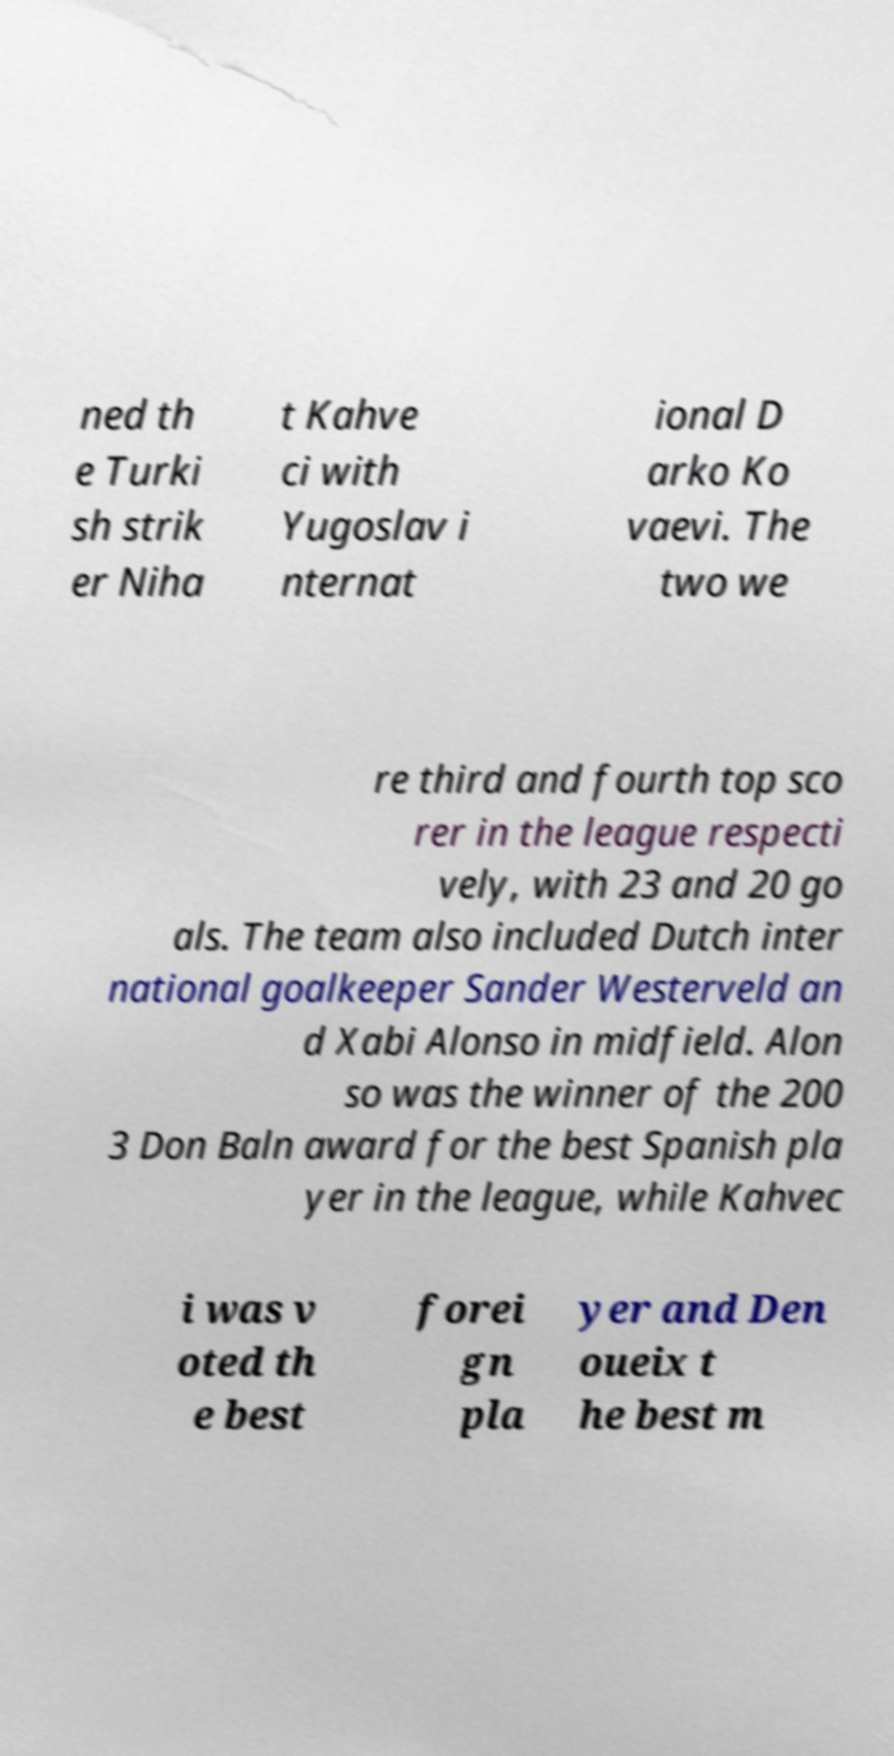Please identify and transcribe the text found in this image. ned th e Turki sh strik er Niha t Kahve ci with Yugoslav i nternat ional D arko Ko vaevi. The two we re third and fourth top sco rer in the league respecti vely, with 23 and 20 go als. The team also included Dutch inter national goalkeeper Sander Westerveld an d Xabi Alonso in midfield. Alon so was the winner of the 200 3 Don Baln award for the best Spanish pla yer in the league, while Kahvec i was v oted th e best forei gn pla yer and Den oueix t he best m 